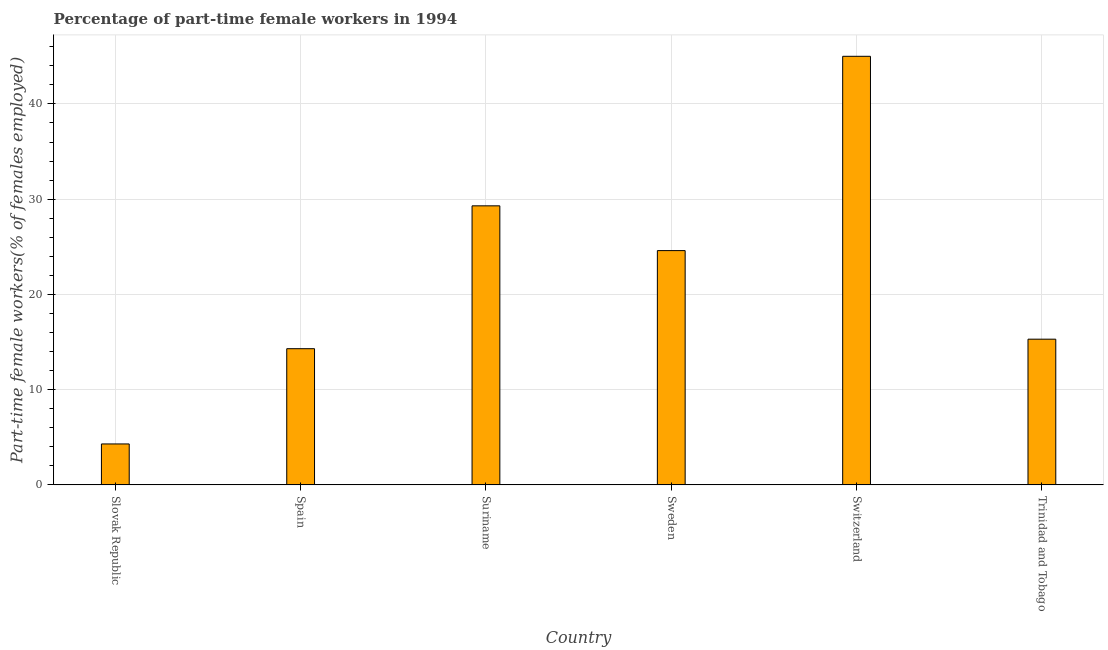Does the graph contain grids?
Keep it short and to the point. Yes. What is the title of the graph?
Your response must be concise. Percentage of part-time female workers in 1994. What is the label or title of the X-axis?
Provide a succinct answer. Country. What is the label or title of the Y-axis?
Make the answer very short. Part-time female workers(% of females employed). What is the percentage of part-time female workers in Suriname?
Your answer should be compact. 29.3. Across all countries, what is the maximum percentage of part-time female workers?
Your response must be concise. 45. Across all countries, what is the minimum percentage of part-time female workers?
Make the answer very short. 4.3. In which country was the percentage of part-time female workers maximum?
Your answer should be very brief. Switzerland. In which country was the percentage of part-time female workers minimum?
Provide a succinct answer. Slovak Republic. What is the sum of the percentage of part-time female workers?
Give a very brief answer. 132.8. What is the difference between the percentage of part-time female workers in Slovak Republic and Sweden?
Your answer should be compact. -20.3. What is the average percentage of part-time female workers per country?
Keep it short and to the point. 22.13. What is the median percentage of part-time female workers?
Offer a terse response. 19.95. In how many countries, is the percentage of part-time female workers greater than 40 %?
Ensure brevity in your answer.  1. What is the ratio of the percentage of part-time female workers in Spain to that in Switzerland?
Offer a very short reply. 0.32. Is the percentage of part-time female workers in Suriname less than that in Switzerland?
Make the answer very short. Yes. Is the difference between the percentage of part-time female workers in Slovak Republic and Spain greater than the difference between any two countries?
Provide a succinct answer. No. What is the difference between the highest and the lowest percentage of part-time female workers?
Your response must be concise. 40.7. In how many countries, is the percentage of part-time female workers greater than the average percentage of part-time female workers taken over all countries?
Offer a very short reply. 3. Are all the bars in the graph horizontal?
Keep it short and to the point. No. What is the difference between two consecutive major ticks on the Y-axis?
Give a very brief answer. 10. Are the values on the major ticks of Y-axis written in scientific E-notation?
Keep it short and to the point. No. What is the Part-time female workers(% of females employed) in Slovak Republic?
Ensure brevity in your answer.  4.3. What is the Part-time female workers(% of females employed) of Spain?
Keep it short and to the point. 14.3. What is the Part-time female workers(% of females employed) in Suriname?
Make the answer very short. 29.3. What is the Part-time female workers(% of females employed) in Sweden?
Keep it short and to the point. 24.6. What is the Part-time female workers(% of females employed) of Switzerland?
Give a very brief answer. 45. What is the Part-time female workers(% of females employed) of Trinidad and Tobago?
Your answer should be very brief. 15.3. What is the difference between the Part-time female workers(% of females employed) in Slovak Republic and Spain?
Make the answer very short. -10. What is the difference between the Part-time female workers(% of females employed) in Slovak Republic and Sweden?
Your response must be concise. -20.3. What is the difference between the Part-time female workers(% of females employed) in Slovak Republic and Switzerland?
Offer a terse response. -40.7. What is the difference between the Part-time female workers(% of females employed) in Slovak Republic and Trinidad and Tobago?
Your answer should be very brief. -11. What is the difference between the Part-time female workers(% of females employed) in Spain and Suriname?
Offer a terse response. -15. What is the difference between the Part-time female workers(% of females employed) in Spain and Switzerland?
Your answer should be compact. -30.7. What is the difference between the Part-time female workers(% of females employed) in Suriname and Sweden?
Make the answer very short. 4.7. What is the difference between the Part-time female workers(% of females employed) in Suriname and Switzerland?
Give a very brief answer. -15.7. What is the difference between the Part-time female workers(% of females employed) in Suriname and Trinidad and Tobago?
Provide a short and direct response. 14. What is the difference between the Part-time female workers(% of females employed) in Sweden and Switzerland?
Your answer should be very brief. -20.4. What is the difference between the Part-time female workers(% of females employed) in Sweden and Trinidad and Tobago?
Make the answer very short. 9.3. What is the difference between the Part-time female workers(% of females employed) in Switzerland and Trinidad and Tobago?
Give a very brief answer. 29.7. What is the ratio of the Part-time female workers(% of females employed) in Slovak Republic to that in Spain?
Provide a short and direct response. 0.3. What is the ratio of the Part-time female workers(% of females employed) in Slovak Republic to that in Suriname?
Make the answer very short. 0.15. What is the ratio of the Part-time female workers(% of females employed) in Slovak Republic to that in Sweden?
Your answer should be compact. 0.17. What is the ratio of the Part-time female workers(% of females employed) in Slovak Republic to that in Switzerland?
Provide a succinct answer. 0.1. What is the ratio of the Part-time female workers(% of females employed) in Slovak Republic to that in Trinidad and Tobago?
Ensure brevity in your answer.  0.28. What is the ratio of the Part-time female workers(% of females employed) in Spain to that in Suriname?
Provide a short and direct response. 0.49. What is the ratio of the Part-time female workers(% of females employed) in Spain to that in Sweden?
Offer a terse response. 0.58. What is the ratio of the Part-time female workers(% of females employed) in Spain to that in Switzerland?
Your response must be concise. 0.32. What is the ratio of the Part-time female workers(% of females employed) in Spain to that in Trinidad and Tobago?
Provide a short and direct response. 0.94. What is the ratio of the Part-time female workers(% of females employed) in Suriname to that in Sweden?
Ensure brevity in your answer.  1.19. What is the ratio of the Part-time female workers(% of females employed) in Suriname to that in Switzerland?
Provide a short and direct response. 0.65. What is the ratio of the Part-time female workers(% of females employed) in Suriname to that in Trinidad and Tobago?
Your answer should be compact. 1.92. What is the ratio of the Part-time female workers(% of females employed) in Sweden to that in Switzerland?
Your answer should be very brief. 0.55. What is the ratio of the Part-time female workers(% of females employed) in Sweden to that in Trinidad and Tobago?
Your answer should be very brief. 1.61. What is the ratio of the Part-time female workers(% of females employed) in Switzerland to that in Trinidad and Tobago?
Keep it short and to the point. 2.94. 